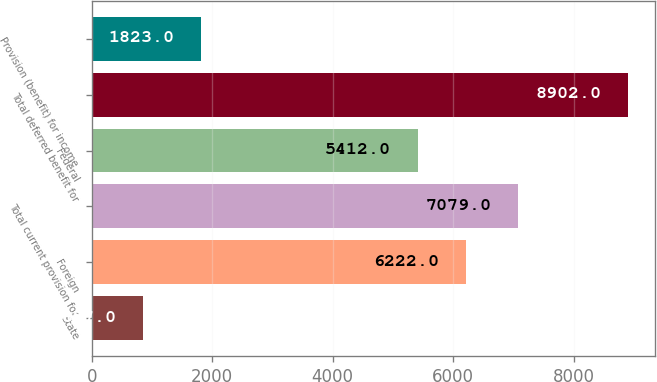Convert chart to OTSL. <chart><loc_0><loc_0><loc_500><loc_500><bar_chart><fcel>State<fcel>Foreign<fcel>Total current provision for<fcel>Federal<fcel>Total deferred benefit for<fcel>Provision (benefit) for income<nl><fcel>857<fcel>6222<fcel>7079<fcel>5412<fcel>8902<fcel>1823<nl></chart> 